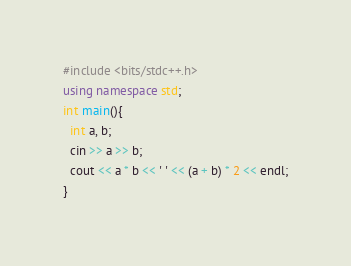Convert code to text. <code><loc_0><loc_0><loc_500><loc_500><_C++_>#include <bits/stdc++.h>
using namespace std;
int main(){
  int a, b;
  cin >> a >> b;
  cout << a * b << ' ' << (a + b) * 2 << endl;
}
</code> 